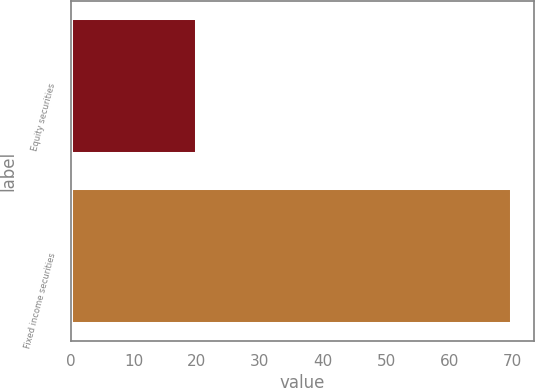Convert chart. <chart><loc_0><loc_0><loc_500><loc_500><bar_chart><fcel>Equity securities<fcel>Fixed income securities<nl><fcel>20<fcel>70<nl></chart> 